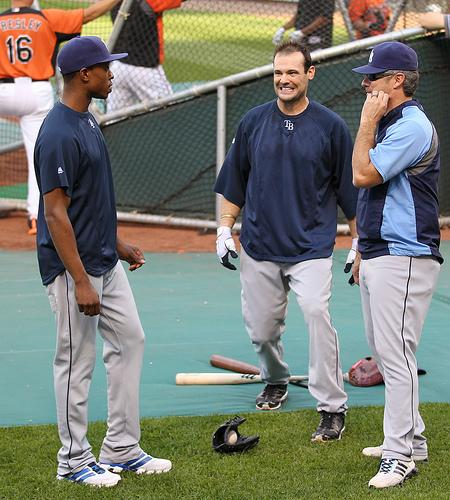Describe the location of the men and the environment in the image. There are three men standing on the grass in a baseball field. Mention an object found in the image that is made of wood. Wooden baseball bats are found in the image. What is the state of the black baseball glove and what is inside it? The black baseball glove is laying in the grass and has a ball in it. What color is the cap worn by the man wearing sunglasses? The man wearing sunglasses is wearing a blue cap. What type of shoes does the white baseball player wear? The white baseball player wears white shoes with blue stripes. What is the jersey color and number of the player in the image? The jersey color is orange and the number is 16. How many baseball bats are laying on the ground? There are two baseball bats laying on the ground. Identify the color of the shirt and the unique feature on its side. The shirt is blue with light blue stripes on its side. Write a short caption for this image. Three baseball players on the field, with bats, gloves, and a ball, ready for some action. What is the emotional expression of the man smiling and any accessories he is wearing? The man has a grin on his face and is wearing a wedding ring. An ice cream vendor is pushing his cart near the baseball players, offering cold treats on a sunny day. No ice cream vendor, cart or sunny day is mentioned in the provided information about the image. A huge scoreboard displays the current score of the game in the background. There is no mention of a scoreboard or game score in the image details. A small dog is playfully running on the grass, chasing its tail. The provided details about the image do not include a dog or any indication of an animal. Do you notice any children playing around the baseball field, maybe trying to catch a foul ball? No children are mentioned in the given information about the image. Can you find a red bicycle leaning against a fence in the image? There is no red bicycle in the given information about the image. Look for a woman wearing a pink dress and holding a baby in her arms. No woman or baby is mentioned in the available information about the image. 